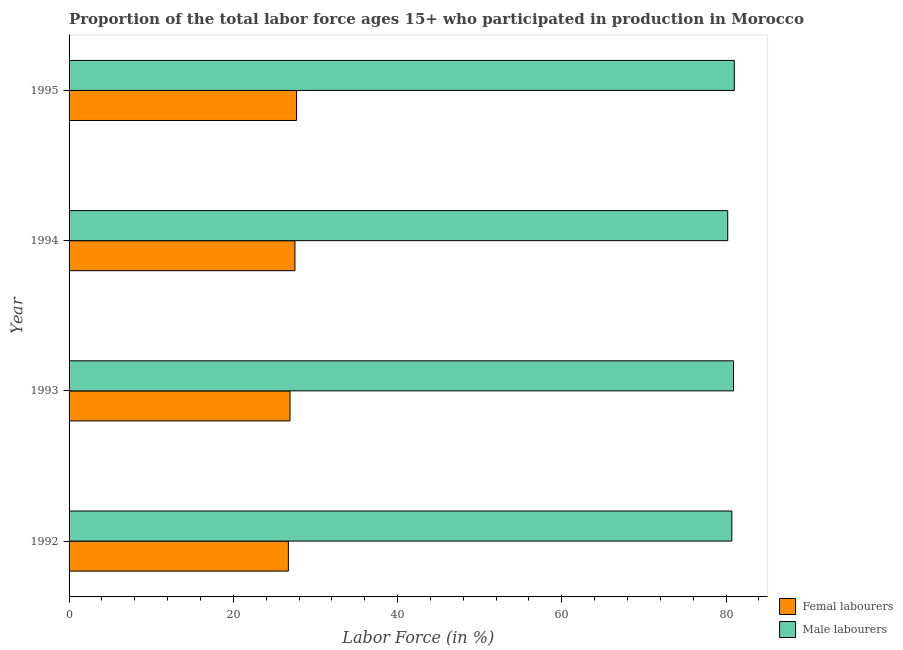How many different coloured bars are there?
Offer a terse response. 2. Are the number of bars on each tick of the Y-axis equal?
Your response must be concise. Yes. How many bars are there on the 4th tick from the bottom?
Offer a terse response. 2. In how many cases, is the number of bars for a given year not equal to the number of legend labels?
Make the answer very short. 0. What is the percentage of female labor force in 1995?
Provide a short and direct response. 27.7. Across all years, what is the minimum percentage of female labor force?
Your answer should be compact. 26.7. In which year was the percentage of female labor force maximum?
Ensure brevity in your answer.  1995. In which year was the percentage of male labour force minimum?
Provide a succinct answer. 1994. What is the total percentage of male labour force in the graph?
Your answer should be compact. 322.8. What is the difference between the percentage of male labour force in 1992 and that in 1994?
Provide a short and direct response. 0.5. What is the difference between the percentage of male labour force in 1994 and the percentage of female labor force in 1993?
Offer a terse response. 53.3. What is the average percentage of female labor force per year?
Keep it short and to the point. 27.2. In the year 1994, what is the difference between the percentage of male labour force and percentage of female labor force?
Ensure brevity in your answer.  52.7. In how many years, is the percentage of male labour force greater than 20 %?
Provide a succinct answer. 4. Is the difference between the percentage of female labor force in 1994 and 1995 greater than the difference between the percentage of male labour force in 1994 and 1995?
Offer a very short reply. Yes. What is the difference between the highest and the second highest percentage of male labour force?
Your response must be concise. 0.1. What is the difference between the highest and the lowest percentage of female labor force?
Your answer should be compact. 1. What does the 1st bar from the top in 1994 represents?
Provide a succinct answer. Male labourers. What does the 1st bar from the bottom in 1992 represents?
Your answer should be very brief. Femal labourers. Where does the legend appear in the graph?
Make the answer very short. Bottom right. What is the title of the graph?
Offer a terse response. Proportion of the total labor force ages 15+ who participated in production in Morocco. What is the label or title of the Y-axis?
Your answer should be very brief. Year. What is the Labor Force (in %) in Femal labourers in 1992?
Offer a terse response. 26.7. What is the Labor Force (in %) in Male labourers in 1992?
Keep it short and to the point. 80.7. What is the Labor Force (in %) of Femal labourers in 1993?
Ensure brevity in your answer.  26.9. What is the Labor Force (in %) in Male labourers in 1993?
Your response must be concise. 80.9. What is the Labor Force (in %) of Male labourers in 1994?
Ensure brevity in your answer.  80.2. What is the Labor Force (in %) of Femal labourers in 1995?
Keep it short and to the point. 27.7. What is the Labor Force (in %) in Male labourers in 1995?
Ensure brevity in your answer.  81. Across all years, what is the maximum Labor Force (in %) in Femal labourers?
Offer a terse response. 27.7. Across all years, what is the minimum Labor Force (in %) in Femal labourers?
Your answer should be very brief. 26.7. Across all years, what is the minimum Labor Force (in %) in Male labourers?
Offer a terse response. 80.2. What is the total Labor Force (in %) of Femal labourers in the graph?
Your response must be concise. 108.8. What is the total Labor Force (in %) of Male labourers in the graph?
Offer a terse response. 322.8. What is the difference between the Labor Force (in %) in Male labourers in 1992 and that in 1993?
Your response must be concise. -0.2. What is the difference between the Labor Force (in %) in Femal labourers in 1992 and that in 1994?
Make the answer very short. -0.8. What is the difference between the Labor Force (in %) in Male labourers in 1993 and that in 1994?
Make the answer very short. 0.7. What is the difference between the Labor Force (in %) of Femal labourers in 1993 and that in 1995?
Keep it short and to the point. -0.8. What is the difference between the Labor Force (in %) in Male labourers in 1993 and that in 1995?
Offer a very short reply. -0.1. What is the difference between the Labor Force (in %) in Male labourers in 1994 and that in 1995?
Your answer should be very brief. -0.8. What is the difference between the Labor Force (in %) of Femal labourers in 1992 and the Labor Force (in %) of Male labourers in 1993?
Give a very brief answer. -54.2. What is the difference between the Labor Force (in %) in Femal labourers in 1992 and the Labor Force (in %) in Male labourers in 1994?
Make the answer very short. -53.5. What is the difference between the Labor Force (in %) in Femal labourers in 1992 and the Labor Force (in %) in Male labourers in 1995?
Keep it short and to the point. -54.3. What is the difference between the Labor Force (in %) of Femal labourers in 1993 and the Labor Force (in %) of Male labourers in 1994?
Offer a very short reply. -53.3. What is the difference between the Labor Force (in %) in Femal labourers in 1993 and the Labor Force (in %) in Male labourers in 1995?
Your answer should be compact. -54.1. What is the difference between the Labor Force (in %) of Femal labourers in 1994 and the Labor Force (in %) of Male labourers in 1995?
Give a very brief answer. -53.5. What is the average Labor Force (in %) in Femal labourers per year?
Ensure brevity in your answer.  27.2. What is the average Labor Force (in %) of Male labourers per year?
Offer a very short reply. 80.7. In the year 1992, what is the difference between the Labor Force (in %) in Femal labourers and Labor Force (in %) in Male labourers?
Provide a short and direct response. -54. In the year 1993, what is the difference between the Labor Force (in %) of Femal labourers and Labor Force (in %) of Male labourers?
Your answer should be compact. -54. In the year 1994, what is the difference between the Labor Force (in %) in Femal labourers and Labor Force (in %) in Male labourers?
Ensure brevity in your answer.  -52.7. In the year 1995, what is the difference between the Labor Force (in %) of Femal labourers and Labor Force (in %) of Male labourers?
Provide a short and direct response. -53.3. What is the ratio of the Labor Force (in %) of Male labourers in 1992 to that in 1993?
Keep it short and to the point. 1. What is the ratio of the Labor Force (in %) in Femal labourers in 1992 to that in 1994?
Make the answer very short. 0.97. What is the ratio of the Labor Force (in %) in Male labourers in 1992 to that in 1994?
Ensure brevity in your answer.  1.01. What is the ratio of the Labor Force (in %) in Femal labourers in 1992 to that in 1995?
Ensure brevity in your answer.  0.96. What is the ratio of the Labor Force (in %) in Male labourers in 1992 to that in 1995?
Give a very brief answer. 1. What is the ratio of the Labor Force (in %) of Femal labourers in 1993 to that in 1994?
Provide a short and direct response. 0.98. What is the ratio of the Labor Force (in %) in Male labourers in 1993 to that in 1994?
Keep it short and to the point. 1.01. What is the ratio of the Labor Force (in %) of Femal labourers in 1993 to that in 1995?
Give a very brief answer. 0.97. What is the ratio of the Labor Force (in %) of Male labourers in 1994 to that in 1995?
Keep it short and to the point. 0.99. What is the difference between the highest and the second highest Labor Force (in %) in Femal labourers?
Ensure brevity in your answer.  0.2. What is the difference between the highest and the lowest Labor Force (in %) in Male labourers?
Provide a succinct answer. 0.8. 